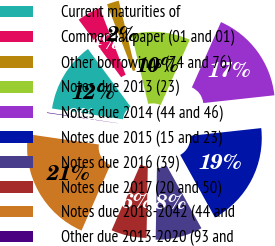<chart> <loc_0><loc_0><loc_500><loc_500><pie_chart><fcel>Current maturities of<fcel>Commercial paper (01 and 01)<fcel>Other borrowings (74 and 76)<fcel>Notes due 2013 (23)<fcel>Notes due 2014 (44 and 46)<fcel>Notes due 2015 (15 and 23)<fcel>Notes due 2016 (39)<fcel>Notes due 2017 (20 and 50)<fcel>Notes due 2018-2042 (44 and<fcel>Other due 2013-2020 (93 and<nl><fcel>12.48%<fcel>4.22%<fcel>2.16%<fcel>10.41%<fcel>16.6%<fcel>18.67%<fcel>8.35%<fcel>6.29%<fcel>20.73%<fcel>0.1%<nl></chart> 